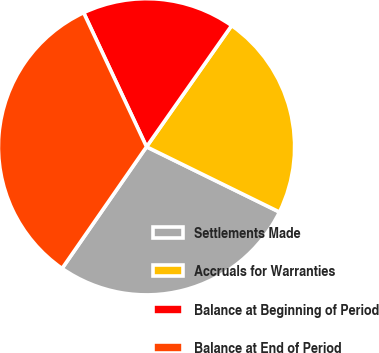Convert chart. <chart><loc_0><loc_0><loc_500><loc_500><pie_chart><fcel>Settlements Made<fcel>Accruals for Warranties<fcel>Balance at Beginning of Period<fcel>Balance at End of Period<nl><fcel>27.39%<fcel>22.52%<fcel>16.72%<fcel>33.36%<nl></chart> 